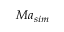<formula> <loc_0><loc_0><loc_500><loc_500>M a _ { s i m }</formula> 